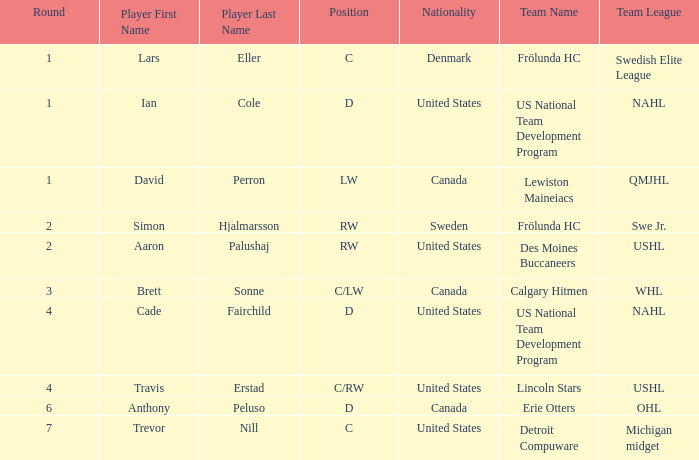What is the highest round of Ian Cole, who played position d from the United States? 1.0. Give me the full table as a dictionary. {'header': ['Round', 'Player First Name', 'Player Last Name', 'Position', 'Nationality', 'Team Name', 'Team League'], 'rows': [['1', 'Lars', 'Eller', 'C', 'Denmark', 'Frölunda HC', 'Swedish Elite League'], ['1', 'Ian', 'Cole', 'D', 'United States', 'US National Team Development Program', 'NAHL'], ['1', 'David', 'Perron', 'LW', 'Canada', 'Lewiston Maineiacs', 'QMJHL'], ['2', 'Simon', 'Hjalmarsson', 'RW', 'Sweden', 'Frölunda HC', 'Swe Jr.'], ['2', 'Aaron', 'Palushaj', 'RW', 'United States', 'Des Moines Buccaneers', 'USHL'], ['3', 'Brett', 'Sonne', 'C/LW', 'Canada', 'Calgary Hitmen', 'WHL'], ['4', 'Cade', 'Fairchild', 'D', 'United States', 'US National Team Development Program', 'NAHL'], ['4', 'Travis', 'Erstad', 'C/RW', 'United States', 'Lincoln Stars', 'USHL'], ['6', 'Anthony', 'Peluso', 'D', 'Canada', 'Erie Otters', 'OHL'], ['7', 'Trevor', 'Nill', 'C', 'United States', 'Detroit Compuware', 'Michigan midget']]} 